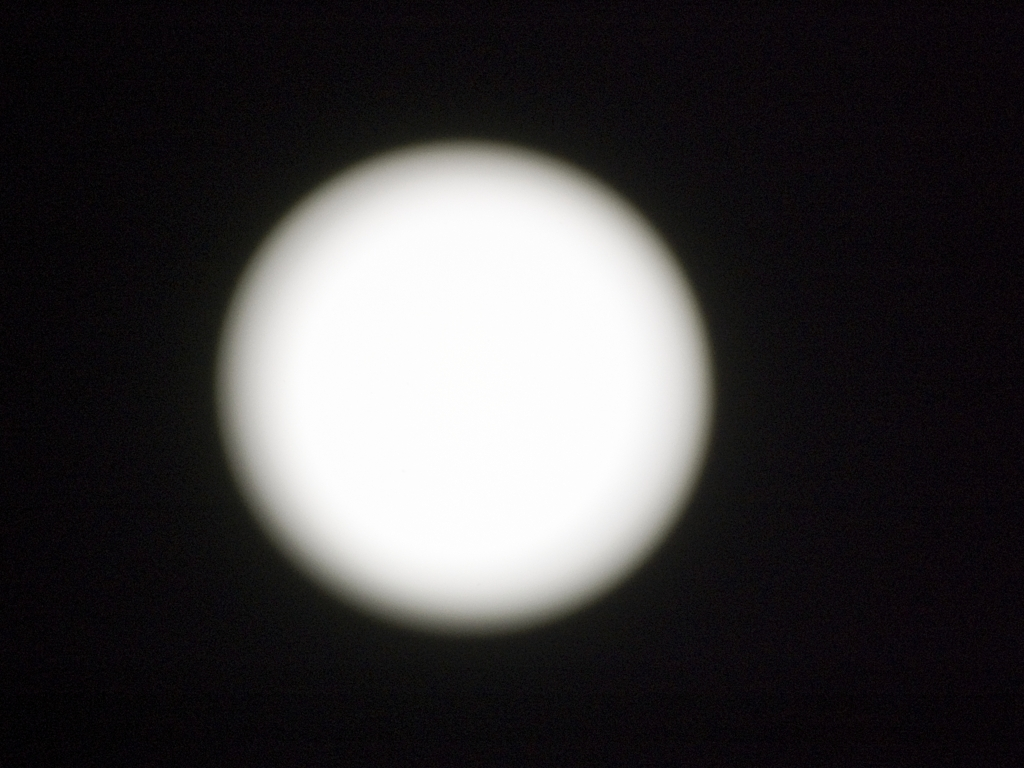Can you describe what we are supposed to be looking at in this image? This image appears to be an overexposed photograph of a bright, celestial body, likely the Moon. However, the excessive brightness and lack of detail prevent a clear observation of the surface features. 